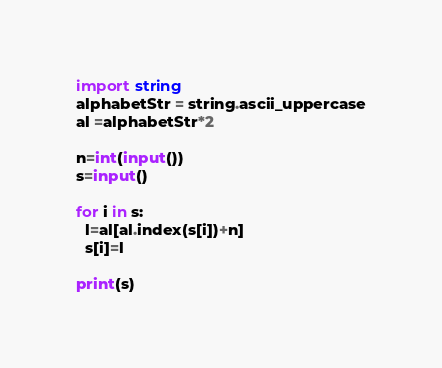Convert code to text. <code><loc_0><loc_0><loc_500><loc_500><_Python_>import string
alphabetStr = string.ascii_uppercase
al =alphabetStr*2

n=int(input())
s=input()

for i in s:
  l=al[al.index(s[i])+n]
  s[i]=l

print(s)</code> 